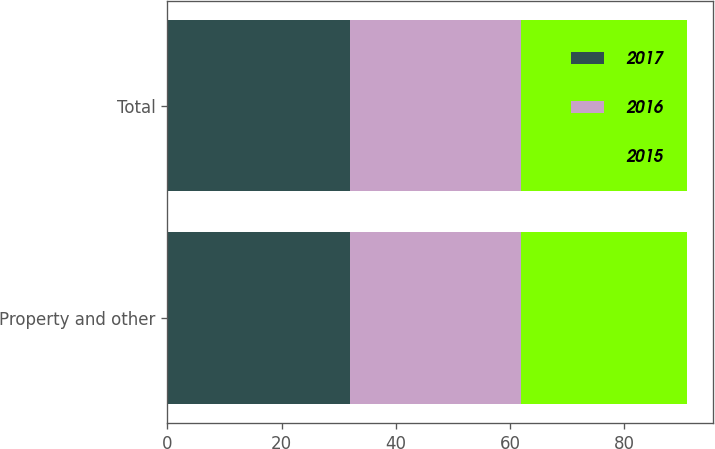Convert chart to OTSL. <chart><loc_0><loc_0><loc_500><loc_500><stacked_bar_chart><ecel><fcel>Property and other<fcel>Total<nl><fcel>2017<fcel>32<fcel>32<nl><fcel>2016<fcel>30<fcel>30<nl><fcel>2015<fcel>29<fcel>29<nl></chart> 